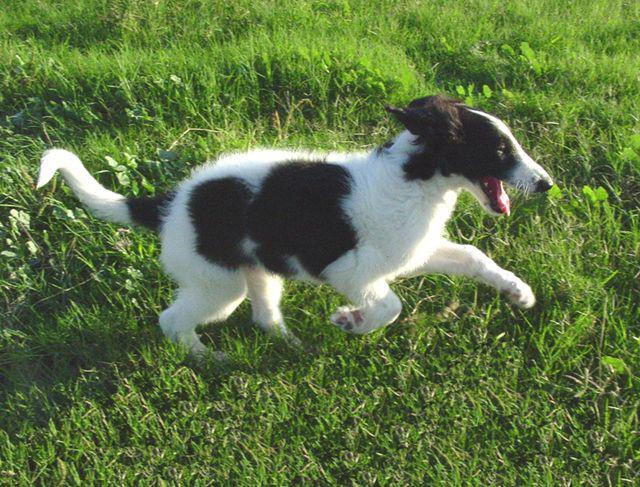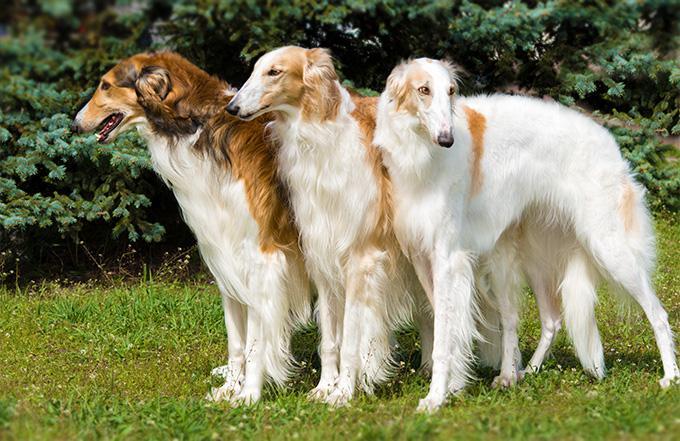The first image is the image on the left, the second image is the image on the right. Given the left and right images, does the statement "One of the images contains exactly three dogs." hold true? Answer yes or no. Yes. 